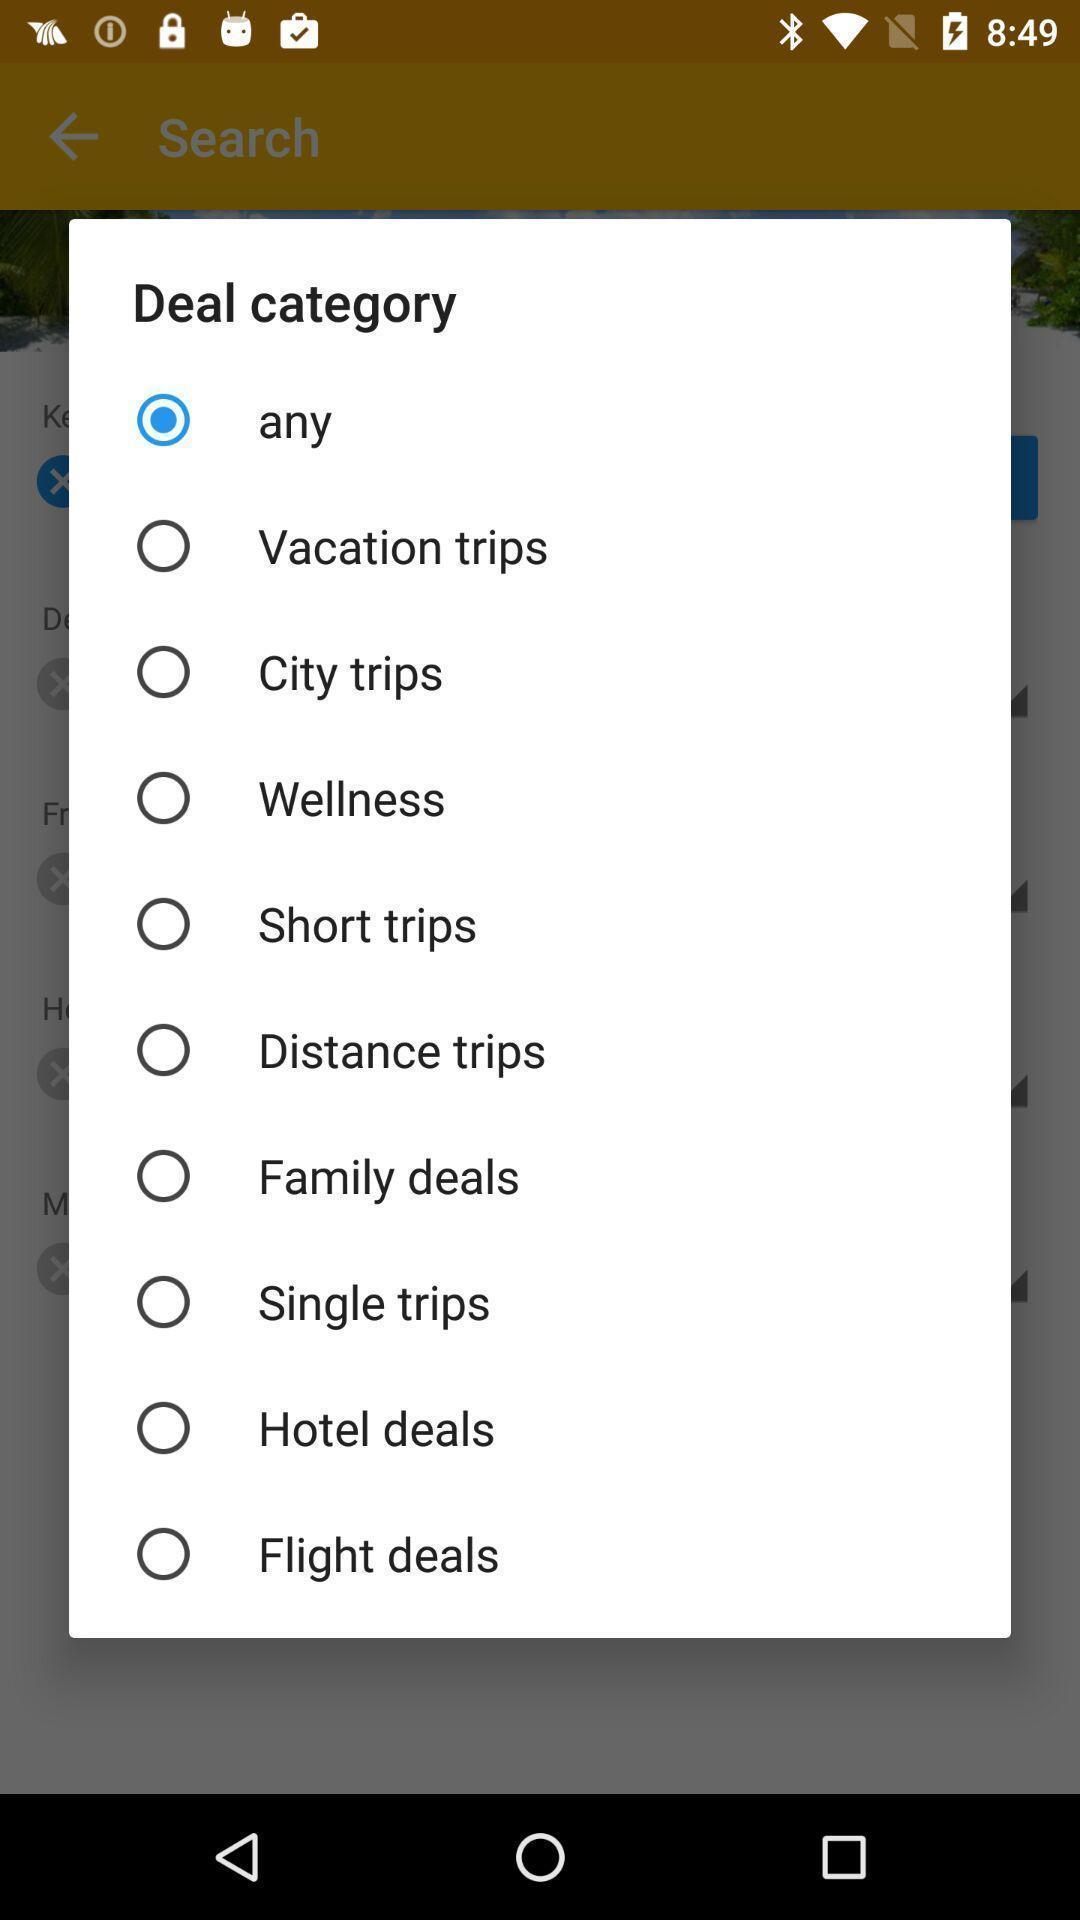Provide a textual representation of this image. Screen displaying the list of categories. 